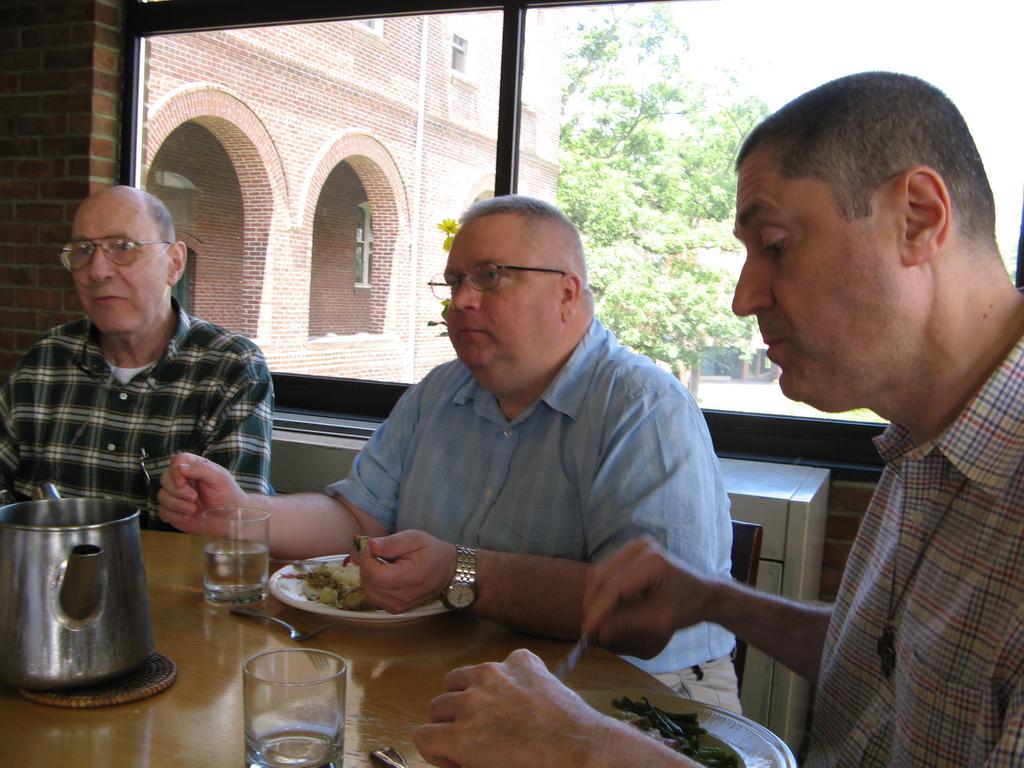Please provide a concise description of this image. There are three man sitting in the chair in front of a table on which some food in the plates and glasses and some jars were placed. Two of them were wearing spectacles. From the window, in the background there are some trees and sky here 